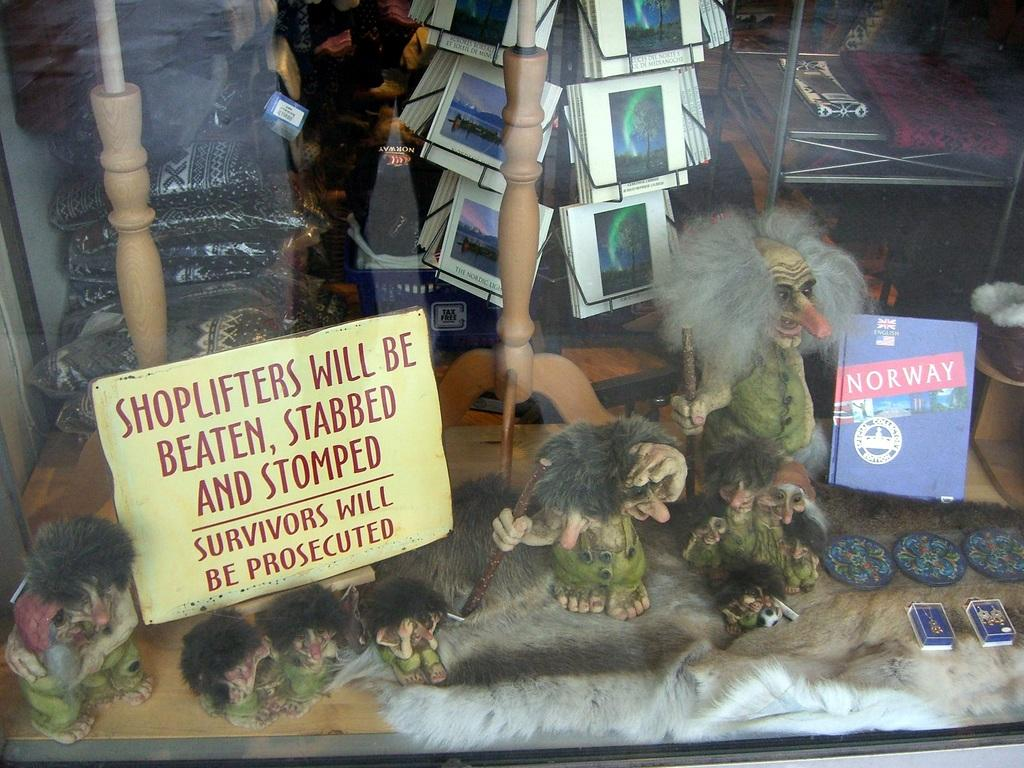<image>
Summarize the visual content of the image. A window display with a warning to shoplifters saying they will be beaten. 